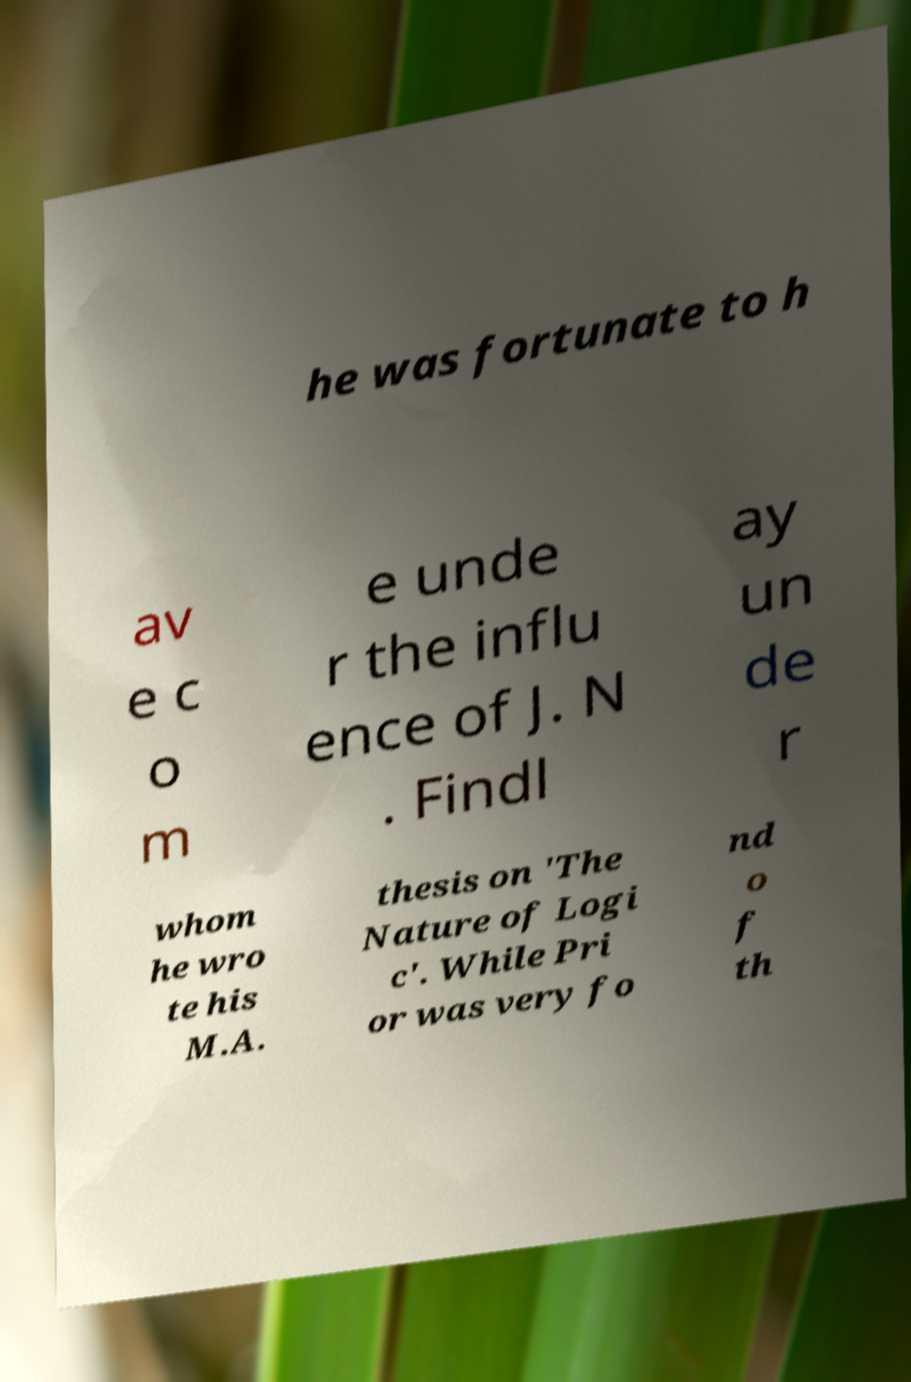There's text embedded in this image that I need extracted. Can you transcribe it verbatim? he was fortunate to h av e c o m e unde r the influ ence of J. N . Findl ay un de r whom he wro te his M.A. thesis on 'The Nature of Logi c'. While Pri or was very fo nd o f th 